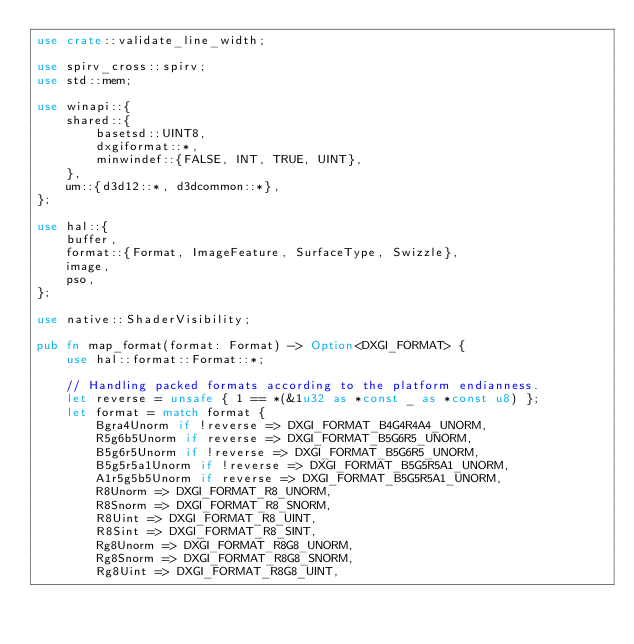<code> <loc_0><loc_0><loc_500><loc_500><_Rust_>use crate::validate_line_width;

use spirv_cross::spirv;
use std::mem;

use winapi::{
    shared::{
        basetsd::UINT8,
        dxgiformat::*,
        minwindef::{FALSE, INT, TRUE, UINT},
    },
    um::{d3d12::*, d3dcommon::*},
};

use hal::{
    buffer,
    format::{Format, ImageFeature, SurfaceType, Swizzle},
    image,
    pso,
};

use native::ShaderVisibility;

pub fn map_format(format: Format) -> Option<DXGI_FORMAT> {
    use hal::format::Format::*;

    // Handling packed formats according to the platform endianness.
    let reverse = unsafe { 1 == *(&1u32 as *const _ as *const u8) };
    let format = match format {
        Bgra4Unorm if !reverse => DXGI_FORMAT_B4G4R4A4_UNORM,
        R5g6b5Unorm if reverse => DXGI_FORMAT_B5G6R5_UNORM,
        B5g6r5Unorm if !reverse => DXGI_FORMAT_B5G6R5_UNORM,
        B5g5r5a1Unorm if !reverse => DXGI_FORMAT_B5G5R5A1_UNORM,
        A1r5g5b5Unorm if reverse => DXGI_FORMAT_B5G5R5A1_UNORM,
        R8Unorm => DXGI_FORMAT_R8_UNORM,
        R8Snorm => DXGI_FORMAT_R8_SNORM,
        R8Uint => DXGI_FORMAT_R8_UINT,
        R8Sint => DXGI_FORMAT_R8_SINT,
        Rg8Unorm => DXGI_FORMAT_R8G8_UNORM,
        Rg8Snorm => DXGI_FORMAT_R8G8_SNORM,
        Rg8Uint => DXGI_FORMAT_R8G8_UINT,</code> 